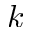<formula> <loc_0><loc_0><loc_500><loc_500>k</formula> 